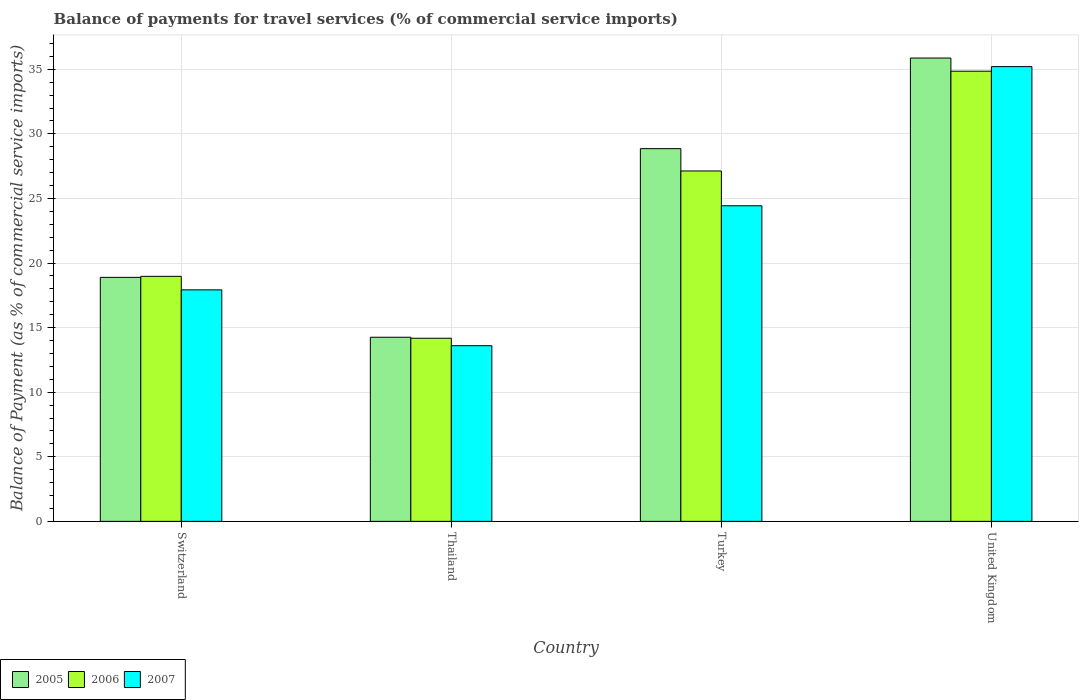How many different coloured bars are there?
Keep it short and to the point. 3. How many groups of bars are there?
Your response must be concise. 4. Are the number of bars per tick equal to the number of legend labels?
Provide a succinct answer. Yes. Are the number of bars on each tick of the X-axis equal?
Provide a succinct answer. Yes. How many bars are there on the 1st tick from the right?
Ensure brevity in your answer.  3. What is the label of the 2nd group of bars from the left?
Your answer should be very brief. Thailand. In how many cases, is the number of bars for a given country not equal to the number of legend labels?
Offer a very short reply. 0. What is the balance of payments for travel services in 2005 in Switzerland?
Your answer should be very brief. 18.89. Across all countries, what is the maximum balance of payments for travel services in 2006?
Offer a very short reply. 34.86. Across all countries, what is the minimum balance of payments for travel services in 2005?
Your response must be concise. 14.26. In which country was the balance of payments for travel services in 2007 minimum?
Provide a succinct answer. Thailand. What is the total balance of payments for travel services in 2006 in the graph?
Give a very brief answer. 95.14. What is the difference between the balance of payments for travel services in 2007 in Turkey and that in United Kingdom?
Ensure brevity in your answer.  -10.77. What is the difference between the balance of payments for travel services in 2006 in Turkey and the balance of payments for travel services in 2005 in United Kingdom?
Give a very brief answer. -8.74. What is the average balance of payments for travel services in 2007 per country?
Your response must be concise. 22.79. What is the difference between the balance of payments for travel services of/in 2007 and balance of payments for travel services of/in 2006 in Thailand?
Your answer should be compact. -0.58. In how many countries, is the balance of payments for travel services in 2005 greater than 33 %?
Your answer should be very brief. 1. What is the ratio of the balance of payments for travel services in 2007 in Thailand to that in United Kingdom?
Offer a very short reply. 0.39. Is the balance of payments for travel services in 2007 in Switzerland less than that in Turkey?
Your answer should be very brief. Yes. Is the difference between the balance of payments for travel services in 2007 in Thailand and Turkey greater than the difference between the balance of payments for travel services in 2006 in Thailand and Turkey?
Provide a succinct answer. Yes. What is the difference between the highest and the second highest balance of payments for travel services in 2007?
Ensure brevity in your answer.  6.51. What is the difference between the highest and the lowest balance of payments for travel services in 2005?
Ensure brevity in your answer.  21.62. In how many countries, is the balance of payments for travel services in 2005 greater than the average balance of payments for travel services in 2005 taken over all countries?
Keep it short and to the point. 2. Is the sum of the balance of payments for travel services in 2006 in Switzerland and Thailand greater than the maximum balance of payments for travel services in 2005 across all countries?
Your response must be concise. No. What does the 1st bar from the right in Turkey represents?
Make the answer very short. 2007. Is it the case that in every country, the sum of the balance of payments for travel services in 2007 and balance of payments for travel services in 2006 is greater than the balance of payments for travel services in 2005?
Provide a short and direct response. Yes. What is the difference between two consecutive major ticks on the Y-axis?
Offer a very short reply. 5. Are the values on the major ticks of Y-axis written in scientific E-notation?
Make the answer very short. No. Does the graph contain any zero values?
Your answer should be very brief. No. How are the legend labels stacked?
Keep it short and to the point. Horizontal. What is the title of the graph?
Offer a very short reply. Balance of payments for travel services (% of commercial service imports). What is the label or title of the X-axis?
Give a very brief answer. Country. What is the label or title of the Y-axis?
Your answer should be very brief. Balance of Payment (as % of commercial service imports). What is the Balance of Payment (as % of commercial service imports) in 2005 in Switzerland?
Give a very brief answer. 18.89. What is the Balance of Payment (as % of commercial service imports) of 2006 in Switzerland?
Your response must be concise. 18.97. What is the Balance of Payment (as % of commercial service imports) in 2007 in Switzerland?
Your answer should be very brief. 17.92. What is the Balance of Payment (as % of commercial service imports) in 2005 in Thailand?
Your response must be concise. 14.26. What is the Balance of Payment (as % of commercial service imports) of 2006 in Thailand?
Give a very brief answer. 14.18. What is the Balance of Payment (as % of commercial service imports) of 2007 in Thailand?
Provide a short and direct response. 13.6. What is the Balance of Payment (as % of commercial service imports) in 2005 in Turkey?
Make the answer very short. 28.86. What is the Balance of Payment (as % of commercial service imports) of 2006 in Turkey?
Ensure brevity in your answer.  27.13. What is the Balance of Payment (as % of commercial service imports) of 2007 in Turkey?
Give a very brief answer. 24.44. What is the Balance of Payment (as % of commercial service imports) of 2005 in United Kingdom?
Ensure brevity in your answer.  35.87. What is the Balance of Payment (as % of commercial service imports) of 2006 in United Kingdom?
Give a very brief answer. 34.86. What is the Balance of Payment (as % of commercial service imports) of 2007 in United Kingdom?
Provide a short and direct response. 35.21. Across all countries, what is the maximum Balance of Payment (as % of commercial service imports) in 2005?
Your response must be concise. 35.87. Across all countries, what is the maximum Balance of Payment (as % of commercial service imports) in 2006?
Offer a terse response. 34.86. Across all countries, what is the maximum Balance of Payment (as % of commercial service imports) in 2007?
Make the answer very short. 35.21. Across all countries, what is the minimum Balance of Payment (as % of commercial service imports) of 2005?
Your answer should be compact. 14.26. Across all countries, what is the minimum Balance of Payment (as % of commercial service imports) in 2006?
Provide a succinct answer. 14.18. Across all countries, what is the minimum Balance of Payment (as % of commercial service imports) in 2007?
Give a very brief answer. 13.6. What is the total Balance of Payment (as % of commercial service imports) of 2005 in the graph?
Make the answer very short. 97.88. What is the total Balance of Payment (as % of commercial service imports) of 2006 in the graph?
Your answer should be very brief. 95.14. What is the total Balance of Payment (as % of commercial service imports) in 2007 in the graph?
Provide a succinct answer. 91.17. What is the difference between the Balance of Payment (as % of commercial service imports) in 2005 in Switzerland and that in Thailand?
Provide a short and direct response. 4.64. What is the difference between the Balance of Payment (as % of commercial service imports) of 2006 in Switzerland and that in Thailand?
Your response must be concise. 4.79. What is the difference between the Balance of Payment (as % of commercial service imports) of 2007 in Switzerland and that in Thailand?
Make the answer very short. 4.32. What is the difference between the Balance of Payment (as % of commercial service imports) of 2005 in Switzerland and that in Turkey?
Your answer should be compact. -9.97. What is the difference between the Balance of Payment (as % of commercial service imports) of 2006 in Switzerland and that in Turkey?
Keep it short and to the point. -8.16. What is the difference between the Balance of Payment (as % of commercial service imports) of 2007 in Switzerland and that in Turkey?
Ensure brevity in your answer.  -6.51. What is the difference between the Balance of Payment (as % of commercial service imports) of 2005 in Switzerland and that in United Kingdom?
Provide a short and direct response. -16.98. What is the difference between the Balance of Payment (as % of commercial service imports) of 2006 in Switzerland and that in United Kingdom?
Your response must be concise. -15.88. What is the difference between the Balance of Payment (as % of commercial service imports) in 2007 in Switzerland and that in United Kingdom?
Your answer should be compact. -17.29. What is the difference between the Balance of Payment (as % of commercial service imports) in 2005 in Thailand and that in Turkey?
Offer a very short reply. -14.6. What is the difference between the Balance of Payment (as % of commercial service imports) in 2006 in Thailand and that in Turkey?
Your answer should be compact. -12.95. What is the difference between the Balance of Payment (as % of commercial service imports) of 2007 in Thailand and that in Turkey?
Your response must be concise. -10.84. What is the difference between the Balance of Payment (as % of commercial service imports) of 2005 in Thailand and that in United Kingdom?
Offer a terse response. -21.62. What is the difference between the Balance of Payment (as % of commercial service imports) of 2006 in Thailand and that in United Kingdom?
Your answer should be compact. -20.68. What is the difference between the Balance of Payment (as % of commercial service imports) of 2007 in Thailand and that in United Kingdom?
Offer a very short reply. -21.61. What is the difference between the Balance of Payment (as % of commercial service imports) in 2005 in Turkey and that in United Kingdom?
Make the answer very short. -7.02. What is the difference between the Balance of Payment (as % of commercial service imports) in 2006 in Turkey and that in United Kingdom?
Your response must be concise. -7.72. What is the difference between the Balance of Payment (as % of commercial service imports) in 2007 in Turkey and that in United Kingdom?
Give a very brief answer. -10.77. What is the difference between the Balance of Payment (as % of commercial service imports) in 2005 in Switzerland and the Balance of Payment (as % of commercial service imports) in 2006 in Thailand?
Keep it short and to the point. 4.71. What is the difference between the Balance of Payment (as % of commercial service imports) in 2005 in Switzerland and the Balance of Payment (as % of commercial service imports) in 2007 in Thailand?
Your answer should be compact. 5.29. What is the difference between the Balance of Payment (as % of commercial service imports) in 2006 in Switzerland and the Balance of Payment (as % of commercial service imports) in 2007 in Thailand?
Offer a terse response. 5.37. What is the difference between the Balance of Payment (as % of commercial service imports) of 2005 in Switzerland and the Balance of Payment (as % of commercial service imports) of 2006 in Turkey?
Offer a terse response. -8.24. What is the difference between the Balance of Payment (as % of commercial service imports) in 2005 in Switzerland and the Balance of Payment (as % of commercial service imports) in 2007 in Turkey?
Keep it short and to the point. -5.54. What is the difference between the Balance of Payment (as % of commercial service imports) in 2006 in Switzerland and the Balance of Payment (as % of commercial service imports) in 2007 in Turkey?
Your answer should be compact. -5.46. What is the difference between the Balance of Payment (as % of commercial service imports) of 2005 in Switzerland and the Balance of Payment (as % of commercial service imports) of 2006 in United Kingdom?
Give a very brief answer. -15.96. What is the difference between the Balance of Payment (as % of commercial service imports) in 2005 in Switzerland and the Balance of Payment (as % of commercial service imports) in 2007 in United Kingdom?
Give a very brief answer. -16.32. What is the difference between the Balance of Payment (as % of commercial service imports) in 2006 in Switzerland and the Balance of Payment (as % of commercial service imports) in 2007 in United Kingdom?
Ensure brevity in your answer.  -16.24. What is the difference between the Balance of Payment (as % of commercial service imports) of 2005 in Thailand and the Balance of Payment (as % of commercial service imports) of 2006 in Turkey?
Your answer should be compact. -12.87. What is the difference between the Balance of Payment (as % of commercial service imports) in 2005 in Thailand and the Balance of Payment (as % of commercial service imports) in 2007 in Turkey?
Provide a succinct answer. -10.18. What is the difference between the Balance of Payment (as % of commercial service imports) in 2006 in Thailand and the Balance of Payment (as % of commercial service imports) in 2007 in Turkey?
Offer a very short reply. -10.26. What is the difference between the Balance of Payment (as % of commercial service imports) in 2005 in Thailand and the Balance of Payment (as % of commercial service imports) in 2006 in United Kingdom?
Offer a very short reply. -20.6. What is the difference between the Balance of Payment (as % of commercial service imports) of 2005 in Thailand and the Balance of Payment (as % of commercial service imports) of 2007 in United Kingdom?
Ensure brevity in your answer.  -20.95. What is the difference between the Balance of Payment (as % of commercial service imports) of 2006 in Thailand and the Balance of Payment (as % of commercial service imports) of 2007 in United Kingdom?
Offer a very short reply. -21.03. What is the difference between the Balance of Payment (as % of commercial service imports) of 2005 in Turkey and the Balance of Payment (as % of commercial service imports) of 2006 in United Kingdom?
Provide a succinct answer. -6. What is the difference between the Balance of Payment (as % of commercial service imports) in 2005 in Turkey and the Balance of Payment (as % of commercial service imports) in 2007 in United Kingdom?
Give a very brief answer. -6.35. What is the difference between the Balance of Payment (as % of commercial service imports) of 2006 in Turkey and the Balance of Payment (as % of commercial service imports) of 2007 in United Kingdom?
Provide a short and direct response. -8.08. What is the average Balance of Payment (as % of commercial service imports) in 2005 per country?
Provide a succinct answer. 24.47. What is the average Balance of Payment (as % of commercial service imports) of 2006 per country?
Provide a short and direct response. 23.78. What is the average Balance of Payment (as % of commercial service imports) in 2007 per country?
Provide a short and direct response. 22.79. What is the difference between the Balance of Payment (as % of commercial service imports) of 2005 and Balance of Payment (as % of commercial service imports) of 2006 in Switzerland?
Keep it short and to the point. -0.08. What is the difference between the Balance of Payment (as % of commercial service imports) of 2005 and Balance of Payment (as % of commercial service imports) of 2007 in Switzerland?
Offer a very short reply. 0.97. What is the difference between the Balance of Payment (as % of commercial service imports) of 2006 and Balance of Payment (as % of commercial service imports) of 2007 in Switzerland?
Give a very brief answer. 1.05. What is the difference between the Balance of Payment (as % of commercial service imports) of 2005 and Balance of Payment (as % of commercial service imports) of 2006 in Thailand?
Your response must be concise. 0.08. What is the difference between the Balance of Payment (as % of commercial service imports) in 2005 and Balance of Payment (as % of commercial service imports) in 2007 in Thailand?
Make the answer very short. 0.66. What is the difference between the Balance of Payment (as % of commercial service imports) in 2006 and Balance of Payment (as % of commercial service imports) in 2007 in Thailand?
Provide a short and direct response. 0.58. What is the difference between the Balance of Payment (as % of commercial service imports) in 2005 and Balance of Payment (as % of commercial service imports) in 2006 in Turkey?
Provide a short and direct response. 1.73. What is the difference between the Balance of Payment (as % of commercial service imports) in 2005 and Balance of Payment (as % of commercial service imports) in 2007 in Turkey?
Give a very brief answer. 4.42. What is the difference between the Balance of Payment (as % of commercial service imports) in 2006 and Balance of Payment (as % of commercial service imports) in 2007 in Turkey?
Provide a succinct answer. 2.69. What is the difference between the Balance of Payment (as % of commercial service imports) in 2005 and Balance of Payment (as % of commercial service imports) in 2006 in United Kingdom?
Provide a short and direct response. 1.02. What is the difference between the Balance of Payment (as % of commercial service imports) of 2005 and Balance of Payment (as % of commercial service imports) of 2007 in United Kingdom?
Your response must be concise. 0.66. What is the difference between the Balance of Payment (as % of commercial service imports) in 2006 and Balance of Payment (as % of commercial service imports) in 2007 in United Kingdom?
Make the answer very short. -0.35. What is the ratio of the Balance of Payment (as % of commercial service imports) in 2005 in Switzerland to that in Thailand?
Offer a terse response. 1.33. What is the ratio of the Balance of Payment (as % of commercial service imports) of 2006 in Switzerland to that in Thailand?
Your response must be concise. 1.34. What is the ratio of the Balance of Payment (as % of commercial service imports) of 2007 in Switzerland to that in Thailand?
Ensure brevity in your answer.  1.32. What is the ratio of the Balance of Payment (as % of commercial service imports) of 2005 in Switzerland to that in Turkey?
Your answer should be compact. 0.65. What is the ratio of the Balance of Payment (as % of commercial service imports) of 2006 in Switzerland to that in Turkey?
Your answer should be compact. 0.7. What is the ratio of the Balance of Payment (as % of commercial service imports) of 2007 in Switzerland to that in Turkey?
Ensure brevity in your answer.  0.73. What is the ratio of the Balance of Payment (as % of commercial service imports) of 2005 in Switzerland to that in United Kingdom?
Offer a terse response. 0.53. What is the ratio of the Balance of Payment (as % of commercial service imports) in 2006 in Switzerland to that in United Kingdom?
Your response must be concise. 0.54. What is the ratio of the Balance of Payment (as % of commercial service imports) in 2007 in Switzerland to that in United Kingdom?
Ensure brevity in your answer.  0.51. What is the ratio of the Balance of Payment (as % of commercial service imports) in 2005 in Thailand to that in Turkey?
Your response must be concise. 0.49. What is the ratio of the Balance of Payment (as % of commercial service imports) in 2006 in Thailand to that in Turkey?
Offer a very short reply. 0.52. What is the ratio of the Balance of Payment (as % of commercial service imports) in 2007 in Thailand to that in Turkey?
Keep it short and to the point. 0.56. What is the ratio of the Balance of Payment (as % of commercial service imports) in 2005 in Thailand to that in United Kingdom?
Provide a short and direct response. 0.4. What is the ratio of the Balance of Payment (as % of commercial service imports) of 2006 in Thailand to that in United Kingdom?
Offer a very short reply. 0.41. What is the ratio of the Balance of Payment (as % of commercial service imports) in 2007 in Thailand to that in United Kingdom?
Keep it short and to the point. 0.39. What is the ratio of the Balance of Payment (as % of commercial service imports) in 2005 in Turkey to that in United Kingdom?
Provide a short and direct response. 0.8. What is the ratio of the Balance of Payment (as % of commercial service imports) in 2006 in Turkey to that in United Kingdom?
Make the answer very short. 0.78. What is the ratio of the Balance of Payment (as % of commercial service imports) of 2007 in Turkey to that in United Kingdom?
Offer a very short reply. 0.69. What is the difference between the highest and the second highest Balance of Payment (as % of commercial service imports) in 2005?
Offer a terse response. 7.02. What is the difference between the highest and the second highest Balance of Payment (as % of commercial service imports) in 2006?
Provide a short and direct response. 7.72. What is the difference between the highest and the second highest Balance of Payment (as % of commercial service imports) in 2007?
Offer a very short reply. 10.77. What is the difference between the highest and the lowest Balance of Payment (as % of commercial service imports) of 2005?
Give a very brief answer. 21.62. What is the difference between the highest and the lowest Balance of Payment (as % of commercial service imports) in 2006?
Give a very brief answer. 20.68. What is the difference between the highest and the lowest Balance of Payment (as % of commercial service imports) in 2007?
Give a very brief answer. 21.61. 